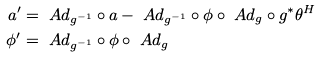Convert formula to latex. <formula><loc_0><loc_0><loc_500><loc_500>a ^ { \prime } & = \ A d _ { g ^ { - 1 } } \circ a - \ A d _ { g ^ { - 1 } } \circ \phi \circ \ A d _ { g } \circ g ^ { * } \theta ^ { H } \\ \phi ^ { \prime } & = \ A d _ { g ^ { - 1 } } \circ \phi \circ \ A d _ { g }</formula> 